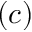Convert formula to latex. <formula><loc_0><loc_0><loc_500><loc_500>( c )</formula> 